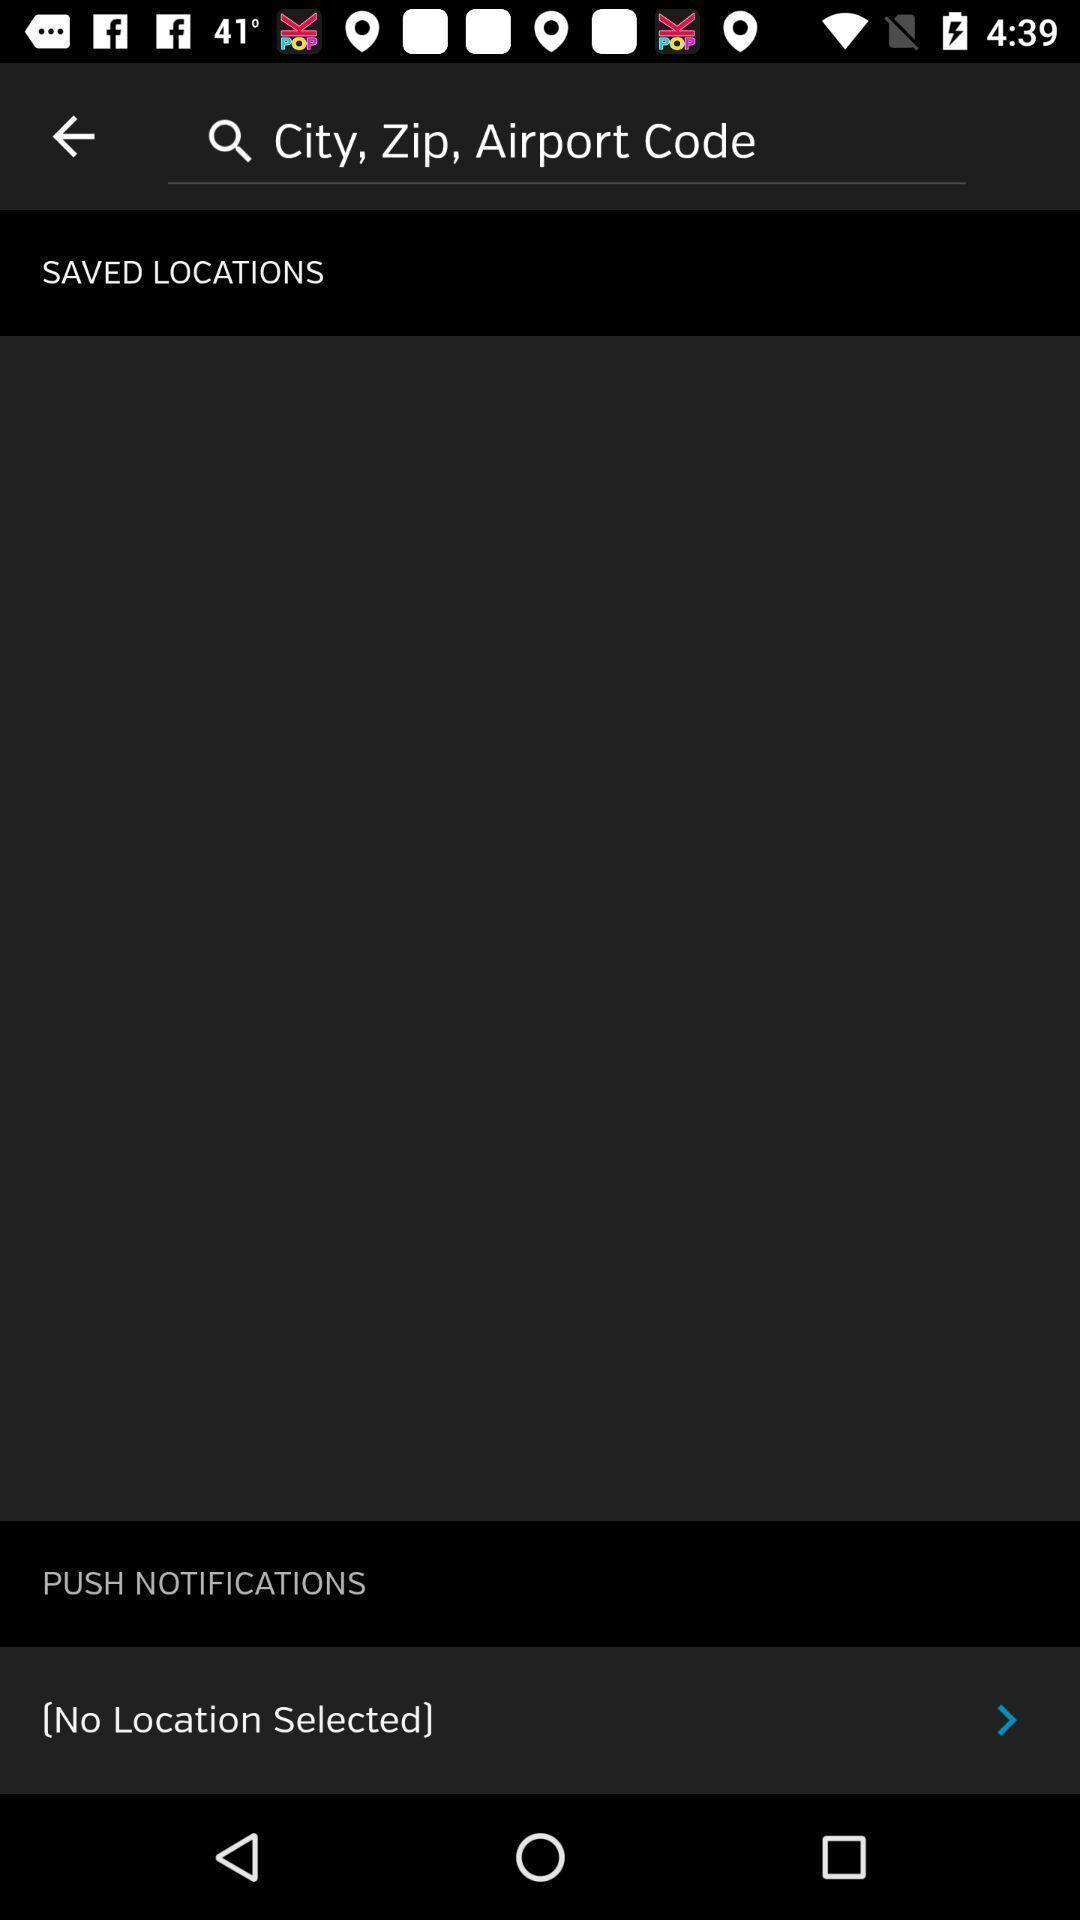What can you discern from this picture? Page displaying the saved locations. 